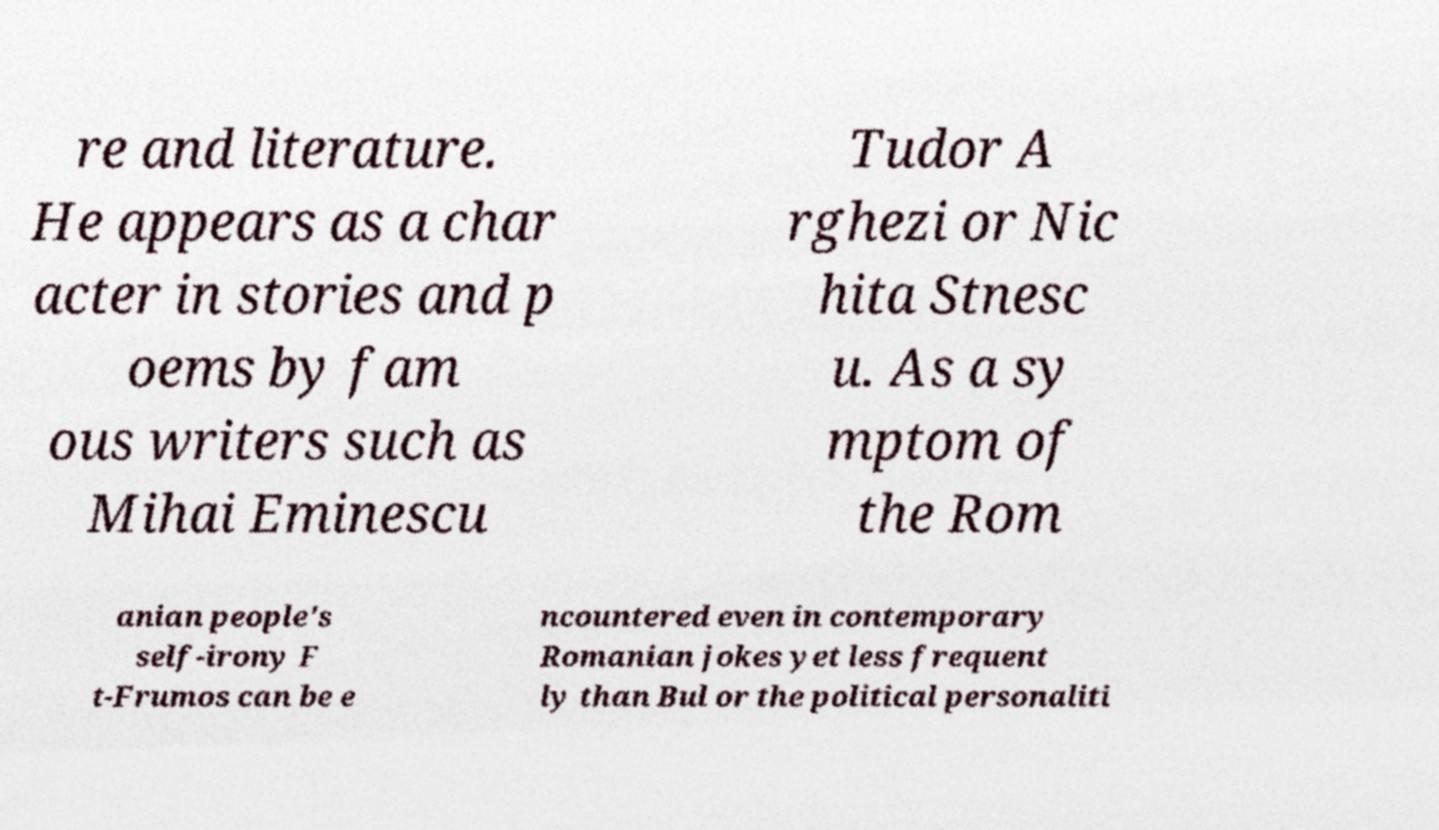Please identify and transcribe the text found in this image. re and literature. He appears as a char acter in stories and p oems by fam ous writers such as Mihai Eminescu Tudor A rghezi or Nic hita Stnesc u. As a sy mptom of the Rom anian people's self-irony F t-Frumos can be e ncountered even in contemporary Romanian jokes yet less frequent ly than Bul or the political personaliti 